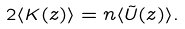<formula> <loc_0><loc_0><loc_500><loc_500>2 \langle K ( z ) \rangle = n \langle \tilde { U } ( z ) \rangle .</formula> 